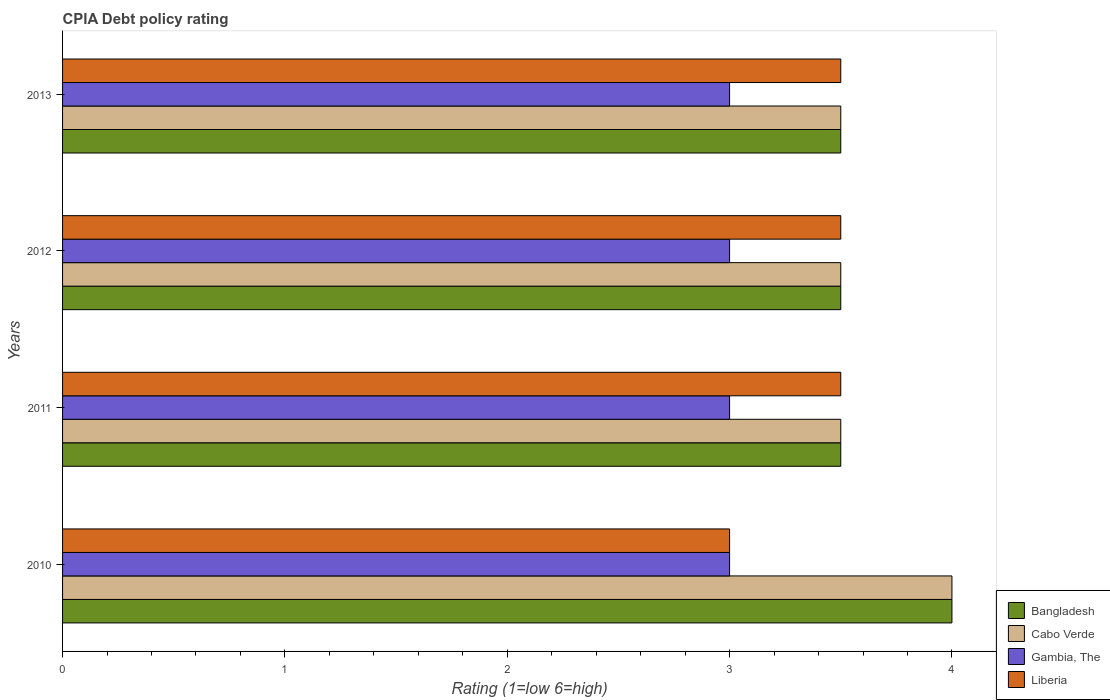How many different coloured bars are there?
Offer a terse response. 4. Are the number of bars per tick equal to the number of legend labels?
Your answer should be compact. Yes. Are the number of bars on each tick of the Y-axis equal?
Make the answer very short. Yes. How many bars are there on the 1st tick from the top?
Offer a terse response. 4. How many bars are there on the 2nd tick from the bottom?
Make the answer very short. 4. What is the label of the 3rd group of bars from the top?
Keep it short and to the point. 2011. In how many cases, is the number of bars for a given year not equal to the number of legend labels?
Your answer should be compact. 0. What is the CPIA rating in Cabo Verde in 2010?
Your response must be concise. 4. Across all years, what is the maximum CPIA rating in Cabo Verde?
Provide a short and direct response. 4. Across all years, what is the minimum CPIA rating in Gambia, The?
Give a very brief answer. 3. In which year was the CPIA rating in Bangladesh minimum?
Ensure brevity in your answer.  2011. What is the difference between the CPIA rating in Bangladesh in 2010 and that in 2013?
Give a very brief answer. 0.5. What is the difference between the CPIA rating in Gambia, The in 2011 and the CPIA rating in Cabo Verde in 2013?
Keep it short and to the point. -0.5. What is the average CPIA rating in Cabo Verde per year?
Ensure brevity in your answer.  3.62. Is the difference between the CPIA rating in Bangladesh in 2011 and 2013 greater than the difference between the CPIA rating in Gambia, The in 2011 and 2013?
Give a very brief answer. No. What is the difference between the highest and the second highest CPIA rating in Gambia, The?
Give a very brief answer. 0. What is the difference between the highest and the lowest CPIA rating in Liberia?
Your answer should be very brief. 0.5. In how many years, is the CPIA rating in Bangladesh greater than the average CPIA rating in Bangladesh taken over all years?
Provide a short and direct response. 1. What does the 3rd bar from the top in 2011 represents?
Your response must be concise. Cabo Verde. What does the 4th bar from the bottom in 2013 represents?
Keep it short and to the point. Liberia. Is it the case that in every year, the sum of the CPIA rating in Cabo Verde and CPIA rating in Gambia, The is greater than the CPIA rating in Liberia?
Offer a terse response. Yes. How many bars are there?
Your answer should be very brief. 16. What is the difference between two consecutive major ticks on the X-axis?
Give a very brief answer. 1. Does the graph contain grids?
Offer a very short reply. No. How are the legend labels stacked?
Give a very brief answer. Vertical. What is the title of the graph?
Offer a very short reply. CPIA Debt policy rating. What is the label or title of the X-axis?
Provide a short and direct response. Rating (1=low 6=high). What is the label or title of the Y-axis?
Your answer should be very brief. Years. What is the Rating (1=low 6=high) of Gambia, The in 2010?
Make the answer very short. 3. What is the Rating (1=low 6=high) in Cabo Verde in 2011?
Offer a very short reply. 3.5. What is the Rating (1=low 6=high) in Gambia, The in 2011?
Give a very brief answer. 3. What is the Rating (1=low 6=high) in Liberia in 2011?
Provide a succinct answer. 3.5. What is the Rating (1=low 6=high) in Bangladesh in 2012?
Provide a short and direct response. 3.5. What is the Rating (1=low 6=high) of Cabo Verde in 2012?
Your answer should be very brief. 3.5. What is the Rating (1=low 6=high) of Bangladesh in 2013?
Keep it short and to the point. 3.5. What is the Rating (1=low 6=high) of Cabo Verde in 2013?
Offer a very short reply. 3.5. What is the Rating (1=low 6=high) of Gambia, The in 2013?
Your response must be concise. 3. Across all years, what is the maximum Rating (1=low 6=high) in Cabo Verde?
Keep it short and to the point. 4. Across all years, what is the maximum Rating (1=low 6=high) in Liberia?
Provide a succinct answer. 3.5. Across all years, what is the minimum Rating (1=low 6=high) of Bangladesh?
Provide a short and direct response. 3.5. Across all years, what is the minimum Rating (1=low 6=high) of Liberia?
Your answer should be very brief. 3. What is the total Rating (1=low 6=high) of Gambia, The in the graph?
Your answer should be very brief. 12. What is the difference between the Rating (1=low 6=high) in Bangladesh in 2010 and that in 2011?
Ensure brevity in your answer.  0.5. What is the difference between the Rating (1=low 6=high) in Cabo Verde in 2010 and that in 2011?
Give a very brief answer. 0.5. What is the difference between the Rating (1=low 6=high) in Gambia, The in 2010 and that in 2011?
Your answer should be very brief. 0. What is the difference between the Rating (1=low 6=high) of Cabo Verde in 2010 and that in 2012?
Provide a succinct answer. 0.5. What is the difference between the Rating (1=low 6=high) of Liberia in 2010 and that in 2012?
Provide a short and direct response. -0.5. What is the difference between the Rating (1=low 6=high) of Cabo Verde in 2010 and that in 2013?
Provide a succinct answer. 0.5. What is the difference between the Rating (1=low 6=high) of Gambia, The in 2010 and that in 2013?
Offer a terse response. 0. What is the difference between the Rating (1=low 6=high) in Bangladesh in 2011 and that in 2012?
Your answer should be compact. 0. What is the difference between the Rating (1=low 6=high) in Cabo Verde in 2011 and that in 2012?
Give a very brief answer. 0. What is the difference between the Rating (1=low 6=high) in Gambia, The in 2011 and that in 2012?
Your answer should be compact. 0. What is the difference between the Rating (1=low 6=high) of Bangladesh in 2011 and that in 2013?
Ensure brevity in your answer.  0. What is the difference between the Rating (1=low 6=high) in Cabo Verde in 2012 and that in 2013?
Make the answer very short. 0. What is the difference between the Rating (1=low 6=high) in Liberia in 2012 and that in 2013?
Your answer should be very brief. 0. What is the difference between the Rating (1=low 6=high) of Bangladesh in 2010 and the Rating (1=low 6=high) of Cabo Verde in 2011?
Ensure brevity in your answer.  0.5. What is the difference between the Rating (1=low 6=high) of Bangladesh in 2010 and the Rating (1=low 6=high) of Gambia, The in 2011?
Your response must be concise. 1. What is the difference between the Rating (1=low 6=high) in Bangladesh in 2010 and the Rating (1=low 6=high) in Liberia in 2011?
Your response must be concise. 0.5. What is the difference between the Rating (1=low 6=high) in Cabo Verde in 2010 and the Rating (1=low 6=high) in Gambia, The in 2011?
Make the answer very short. 1. What is the difference between the Rating (1=low 6=high) of Cabo Verde in 2010 and the Rating (1=low 6=high) of Liberia in 2011?
Offer a very short reply. 0.5. What is the difference between the Rating (1=low 6=high) of Bangladesh in 2010 and the Rating (1=low 6=high) of Cabo Verde in 2012?
Provide a succinct answer. 0.5. What is the difference between the Rating (1=low 6=high) of Cabo Verde in 2010 and the Rating (1=low 6=high) of Gambia, The in 2012?
Your response must be concise. 1. What is the difference between the Rating (1=low 6=high) in Gambia, The in 2010 and the Rating (1=low 6=high) in Liberia in 2012?
Keep it short and to the point. -0.5. What is the difference between the Rating (1=low 6=high) of Bangladesh in 2010 and the Rating (1=low 6=high) of Cabo Verde in 2013?
Offer a very short reply. 0.5. What is the difference between the Rating (1=low 6=high) in Cabo Verde in 2010 and the Rating (1=low 6=high) in Gambia, The in 2013?
Make the answer very short. 1. What is the difference between the Rating (1=low 6=high) of Gambia, The in 2010 and the Rating (1=low 6=high) of Liberia in 2013?
Your answer should be compact. -0.5. What is the difference between the Rating (1=low 6=high) in Bangladesh in 2011 and the Rating (1=low 6=high) in Cabo Verde in 2012?
Your answer should be compact. 0. What is the difference between the Rating (1=low 6=high) of Bangladesh in 2011 and the Rating (1=low 6=high) of Gambia, The in 2013?
Your answer should be compact. 0.5. What is the difference between the Rating (1=low 6=high) in Bangladesh in 2011 and the Rating (1=low 6=high) in Liberia in 2013?
Provide a short and direct response. 0. What is the difference between the Rating (1=low 6=high) in Cabo Verde in 2011 and the Rating (1=low 6=high) in Gambia, The in 2013?
Your response must be concise. 0.5. What is the difference between the Rating (1=low 6=high) of Gambia, The in 2011 and the Rating (1=low 6=high) of Liberia in 2013?
Your response must be concise. -0.5. What is the difference between the Rating (1=low 6=high) in Bangladesh in 2012 and the Rating (1=low 6=high) in Cabo Verde in 2013?
Give a very brief answer. 0. What is the difference between the Rating (1=low 6=high) in Bangladesh in 2012 and the Rating (1=low 6=high) in Gambia, The in 2013?
Keep it short and to the point. 0.5. What is the difference between the Rating (1=low 6=high) of Cabo Verde in 2012 and the Rating (1=low 6=high) of Gambia, The in 2013?
Offer a terse response. 0.5. What is the difference between the Rating (1=low 6=high) of Gambia, The in 2012 and the Rating (1=low 6=high) of Liberia in 2013?
Provide a short and direct response. -0.5. What is the average Rating (1=low 6=high) of Bangladesh per year?
Your answer should be very brief. 3.62. What is the average Rating (1=low 6=high) in Cabo Verde per year?
Keep it short and to the point. 3.62. What is the average Rating (1=low 6=high) in Gambia, The per year?
Provide a short and direct response. 3. What is the average Rating (1=low 6=high) in Liberia per year?
Your response must be concise. 3.38. In the year 2010, what is the difference between the Rating (1=low 6=high) of Bangladesh and Rating (1=low 6=high) of Cabo Verde?
Ensure brevity in your answer.  0. In the year 2010, what is the difference between the Rating (1=low 6=high) of Bangladesh and Rating (1=low 6=high) of Gambia, The?
Provide a short and direct response. 1. In the year 2010, what is the difference between the Rating (1=low 6=high) in Cabo Verde and Rating (1=low 6=high) in Gambia, The?
Give a very brief answer. 1. In the year 2010, what is the difference between the Rating (1=low 6=high) in Gambia, The and Rating (1=low 6=high) in Liberia?
Provide a succinct answer. 0. In the year 2011, what is the difference between the Rating (1=low 6=high) of Bangladesh and Rating (1=low 6=high) of Cabo Verde?
Provide a succinct answer. 0. In the year 2011, what is the difference between the Rating (1=low 6=high) in Bangladesh and Rating (1=low 6=high) in Gambia, The?
Make the answer very short. 0.5. In the year 2011, what is the difference between the Rating (1=low 6=high) in Bangladesh and Rating (1=low 6=high) in Liberia?
Provide a succinct answer. 0. In the year 2012, what is the difference between the Rating (1=low 6=high) of Bangladesh and Rating (1=low 6=high) of Cabo Verde?
Your answer should be compact. 0. In the year 2012, what is the difference between the Rating (1=low 6=high) of Gambia, The and Rating (1=low 6=high) of Liberia?
Make the answer very short. -0.5. In the year 2013, what is the difference between the Rating (1=low 6=high) in Bangladesh and Rating (1=low 6=high) in Cabo Verde?
Your response must be concise. 0. In the year 2013, what is the difference between the Rating (1=low 6=high) in Cabo Verde and Rating (1=low 6=high) in Liberia?
Your answer should be very brief. 0. What is the ratio of the Rating (1=low 6=high) in Bangladesh in 2010 to that in 2011?
Ensure brevity in your answer.  1.14. What is the ratio of the Rating (1=low 6=high) in Gambia, The in 2010 to that in 2011?
Ensure brevity in your answer.  1. What is the ratio of the Rating (1=low 6=high) in Liberia in 2010 to that in 2012?
Your answer should be very brief. 0.86. What is the ratio of the Rating (1=low 6=high) of Gambia, The in 2010 to that in 2013?
Provide a short and direct response. 1. What is the ratio of the Rating (1=low 6=high) of Cabo Verde in 2011 to that in 2012?
Provide a succinct answer. 1. What is the ratio of the Rating (1=low 6=high) in Liberia in 2011 to that in 2012?
Give a very brief answer. 1. What is the ratio of the Rating (1=low 6=high) of Gambia, The in 2012 to that in 2013?
Your answer should be very brief. 1. What is the difference between the highest and the second highest Rating (1=low 6=high) of Bangladesh?
Make the answer very short. 0.5. What is the difference between the highest and the lowest Rating (1=low 6=high) of Cabo Verde?
Offer a very short reply. 0.5. What is the difference between the highest and the lowest Rating (1=low 6=high) of Liberia?
Make the answer very short. 0.5. 